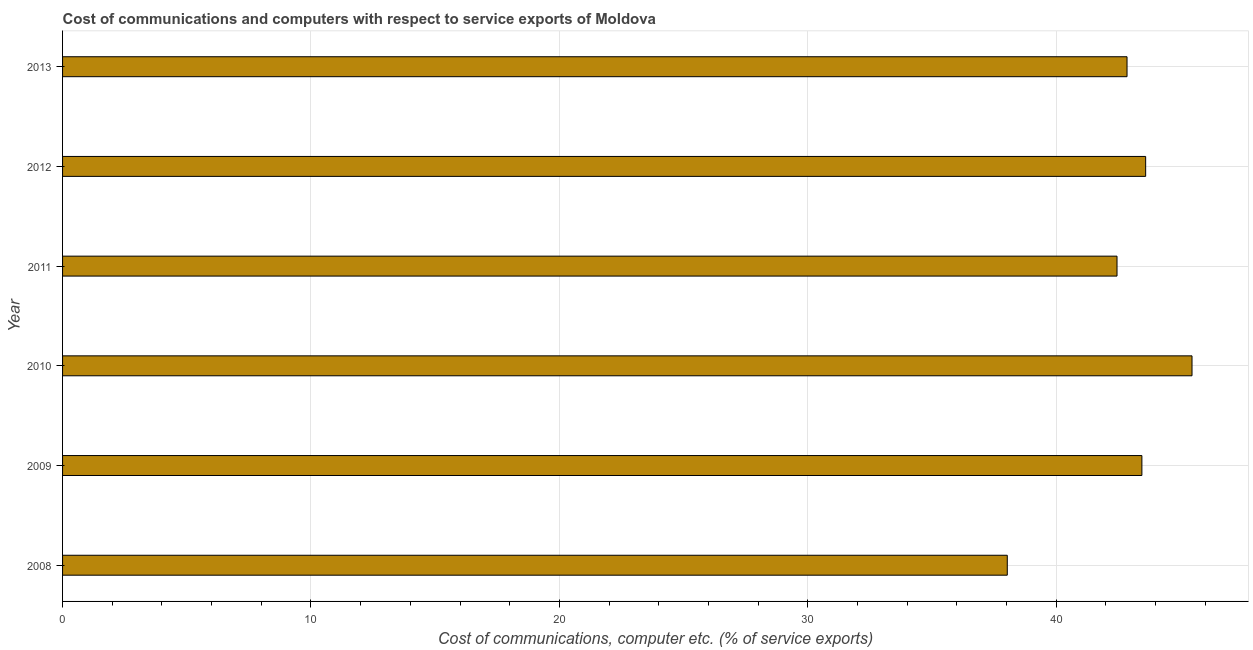Does the graph contain any zero values?
Your response must be concise. No. Does the graph contain grids?
Make the answer very short. Yes. What is the title of the graph?
Your answer should be very brief. Cost of communications and computers with respect to service exports of Moldova. What is the label or title of the X-axis?
Offer a terse response. Cost of communications, computer etc. (% of service exports). What is the cost of communications and computer in 2011?
Keep it short and to the point. 42.45. Across all years, what is the maximum cost of communications and computer?
Offer a terse response. 45.47. Across all years, what is the minimum cost of communications and computer?
Make the answer very short. 38.03. In which year was the cost of communications and computer minimum?
Offer a very short reply. 2008. What is the sum of the cost of communications and computer?
Your answer should be very brief. 255.85. What is the difference between the cost of communications and computer in 2009 and 2012?
Offer a terse response. -0.15. What is the average cost of communications and computer per year?
Your answer should be compact. 42.64. What is the median cost of communications and computer?
Keep it short and to the point. 43.15. Is the difference between the cost of communications and computer in 2010 and 2013 greater than the difference between any two years?
Offer a terse response. No. What is the difference between the highest and the second highest cost of communications and computer?
Provide a succinct answer. 1.87. What is the difference between the highest and the lowest cost of communications and computer?
Your answer should be compact. 7.44. Are all the bars in the graph horizontal?
Provide a succinct answer. Yes. How many years are there in the graph?
Your answer should be compact. 6. What is the difference between two consecutive major ticks on the X-axis?
Keep it short and to the point. 10. What is the Cost of communications, computer etc. (% of service exports) in 2008?
Your answer should be very brief. 38.03. What is the Cost of communications, computer etc. (% of service exports) in 2009?
Make the answer very short. 43.45. What is the Cost of communications, computer etc. (% of service exports) in 2010?
Your response must be concise. 45.47. What is the Cost of communications, computer etc. (% of service exports) in 2011?
Your answer should be very brief. 42.45. What is the Cost of communications, computer etc. (% of service exports) of 2012?
Your answer should be very brief. 43.6. What is the Cost of communications, computer etc. (% of service exports) of 2013?
Your answer should be very brief. 42.85. What is the difference between the Cost of communications, computer etc. (% of service exports) in 2008 and 2009?
Make the answer very short. -5.42. What is the difference between the Cost of communications, computer etc. (% of service exports) in 2008 and 2010?
Your response must be concise. -7.44. What is the difference between the Cost of communications, computer etc. (% of service exports) in 2008 and 2011?
Give a very brief answer. -4.42. What is the difference between the Cost of communications, computer etc. (% of service exports) in 2008 and 2012?
Provide a short and direct response. -5.57. What is the difference between the Cost of communications, computer etc. (% of service exports) in 2008 and 2013?
Make the answer very short. -4.82. What is the difference between the Cost of communications, computer etc. (% of service exports) in 2009 and 2010?
Ensure brevity in your answer.  -2.02. What is the difference between the Cost of communications, computer etc. (% of service exports) in 2009 and 2011?
Give a very brief answer. 1. What is the difference between the Cost of communications, computer etc. (% of service exports) in 2009 and 2012?
Provide a short and direct response. -0.15. What is the difference between the Cost of communications, computer etc. (% of service exports) in 2009 and 2013?
Provide a short and direct response. 0.6. What is the difference between the Cost of communications, computer etc. (% of service exports) in 2010 and 2011?
Give a very brief answer. 3.02. What is the difference between the Cost of communications, computer etc. (% of service exports) in 2010 and 2012?
Keep it short and to the point. 1.87. What is the difference between the Cost of communications, computer etc. (% of service exports) in 2010 and 2013?
Offer a terse response. 2.62. What is the difference between the Cost of communications, computer etc. (% of service exports) in 2011 and 2012?
Offer a very short reply. -1.15. What is the difference between the Cost of communications, computer etc. (% of service exports) in 2011 and 2013?
Your answer should be compact. -0.4. What is the difference between the Cost of communications, computer etc. (% of service exports) in 2012 and 2013?
Provide a succinct answer. 0.75. What is the ratio of the Cost of communications, computer etc. (% of service exports) in 2008 to that in 2009?
Offer a terse response. 0.88. What is the ratio of the Cost of communications, computer etc. (% of service exports) in 2008 to that in 2010?
Provide a succinct answer. 0.84. What is the ratio of the Cost of communications, computer etc. (% of service exports) in 2008 to that in 2011?
Offer a terse response. 0.9. What is the ratio of the Cost of communications, computer etc. (% of service exports) in 2008 to that in 2012?
Your answer should be very brief. 0.87. What is the ratio of the Cost of communications, computer etc. (% of service exports) in 2008 to that in 2013?
Offer a terse response. 0.89. What is the ratio of the Cost of communications, computer etc. (% of service exports) in 2009 to that in 2010?
Give a very brief answer. 0.96. What is the ratio of the Cost of communications, computer etc. (% of service exports) in 2010 to that in 2011?
Your answer should be compact. 1.07. What is the ratio of the Cost of communications, computer etc. (% of service exports) in 2010 to that in 2012?
Offer a terse response. 1.04. What is the ratio of the Cost of communications, computer etc. (% of service exports) in 2010 to that in 2013?
Ensure brevity in your answer.  1.06. What is the ratio of the Cost of communications, computer etc. (% of service exports) in 2011 to that in 2013?
Offer a terse response. 0.99. What is the ratio of the Cost of communications, computer etc. (% of service exports) in 2012 to that in 2013?
Your answer should be compact. 1.02. 